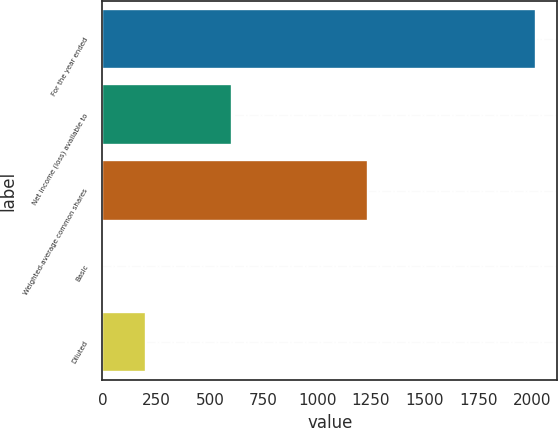Convert chart to OTSL. <chart><loc_0><loc_0><loc_500><loc_500><bar_chart><fcel>For the year ended<fcel>Net income (loss) available to<fcel>Weighted-average common shares<fcel>Basic<fcel>Diluted<nl><fcel>2016<fcel>604.98<fcel>1237.57<fcel>0.27<fcel>201.84<nl></chart> 